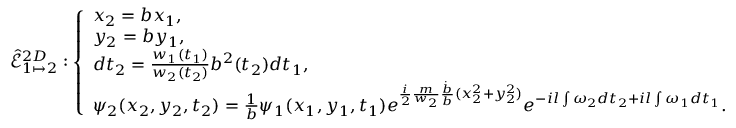<formula> <loc_0><loc_0><loc_500><loc_500>\hat { \mathcal { E } } _ { 1 \mapsto 2 } ^ { 2 D } \colon \left \{ \begin{array} { l l } { x _ { 2 } = b x _ { 1 } , } \\ { y _ { 2 } = b y _ { 1 } , } \\ { d t _ { 2 } = \frac { w _ { 1 } ( t _ { 1 } ) } { w _ { 2 } ( t _ { 2 } ) } b ^ { 2 } ( t _ { 2 } ) d t _ { 1 } , } \\ { \psi _ { 2 } ( x _ { 2 } , y _ { 2 } , t _ { 2 } ) = \frac { 1 } { b } \psi _ { 1 } ( x _ { 1 } , y _ { 1 } , t _ { 1 } ) e ^ { \frac { i } { 2 } \frac { m } { w _ { 2 } } \frac { \dot { b } } { b } ( x _ { 2 } ^ { 2 } + y _ { 2 } ^ { 2 } ) } e ^ { - i l \int \omega _ { 2 } d t _ { 2 } + i l \int \omega _ { 1 } d t _ { 1 } } . } \end{array}</formula> 